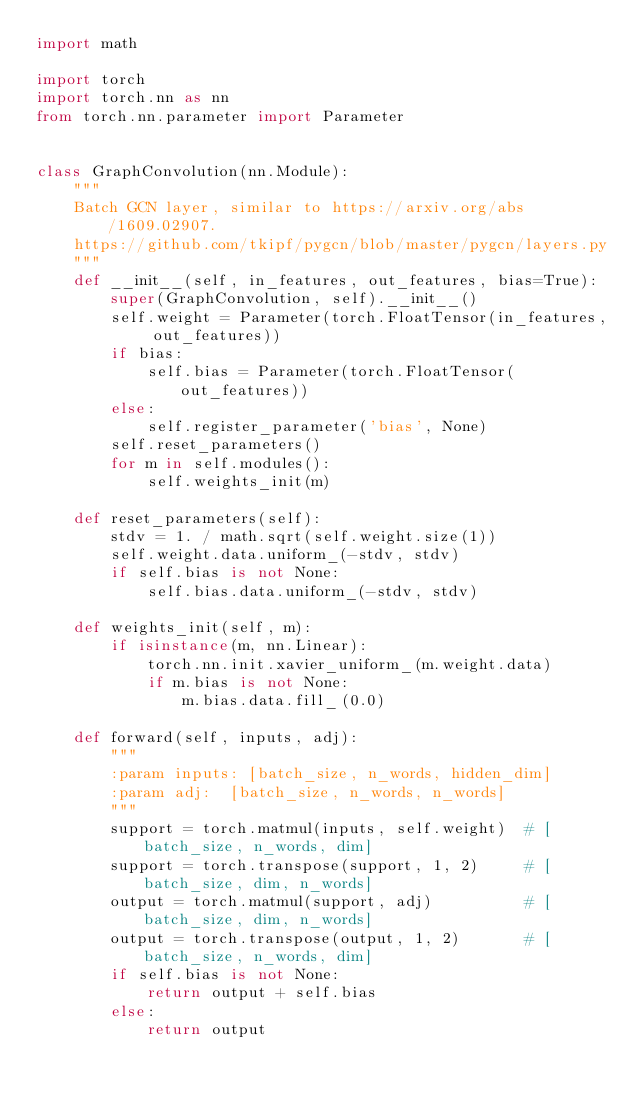Convert code to text. <code><loc_0><loc_0><loc_500><loc_500><_Python_>import math

import torch
import torch.nn as nn
from torch.nn.parameter import Parameter


class GraphConvolution(nn.Module):
    """
    Batch GCN layer, similar to https://arxiv.org/abs/1609.02907.
    https://github.com/tkipf/pygcn/blob/master/pygcn/layers.py
    """
    def __init__(self, in_features, out_features, bias=True):
        super(GraphConvolution, self).__init__()
        self.weight = Parameter(torch.FloatTensor(in_features, out_features))
        if bias:
            self.bias = Parameter(torch.FloatTensor(out_features))
        else:
            self.register_parameter('bias', None)
        self.reset_parameters()
        for m in self.modules():
            self.weights_init(m)

    def reset_parameters(self):
        stdv = 1. / math.sqrt(self.weight.size(1))
        self.weight.data.uniform_(-stdv, stdv)
        if self.bias is not None:
            self.bias.data.uniform_(-stdv, stdv)

    def weights_init(self, m):
        if isinstance(m, nn.Linear):
            torch.nn.init.xavier_uniform_(m.weight.data)
            if m.bias is not None:
                m.bias.data.fill_(0.0)

    def forward(self, inputs, adj):
        """
        :param inputs: [batch_size, n_words, hidden_dim]
        :param adj:  [batch_size, n_words, n_words]
        """
        support = torch.matmul(inputs, self.weight)  # [batch_size, n_words, dim]
        support = torch.transpose(support, 1, 2)     # [batch_size, dim, n_words]
        output = torch.matmul(support, adj)          # [batch_size, dim, n_words]
        output = torch.transpose(output, 1, 2)       # [batch_size, n_words, dim]
        if self.bias is not None:
            return output + self.bias
        else:
            return output
</code> 